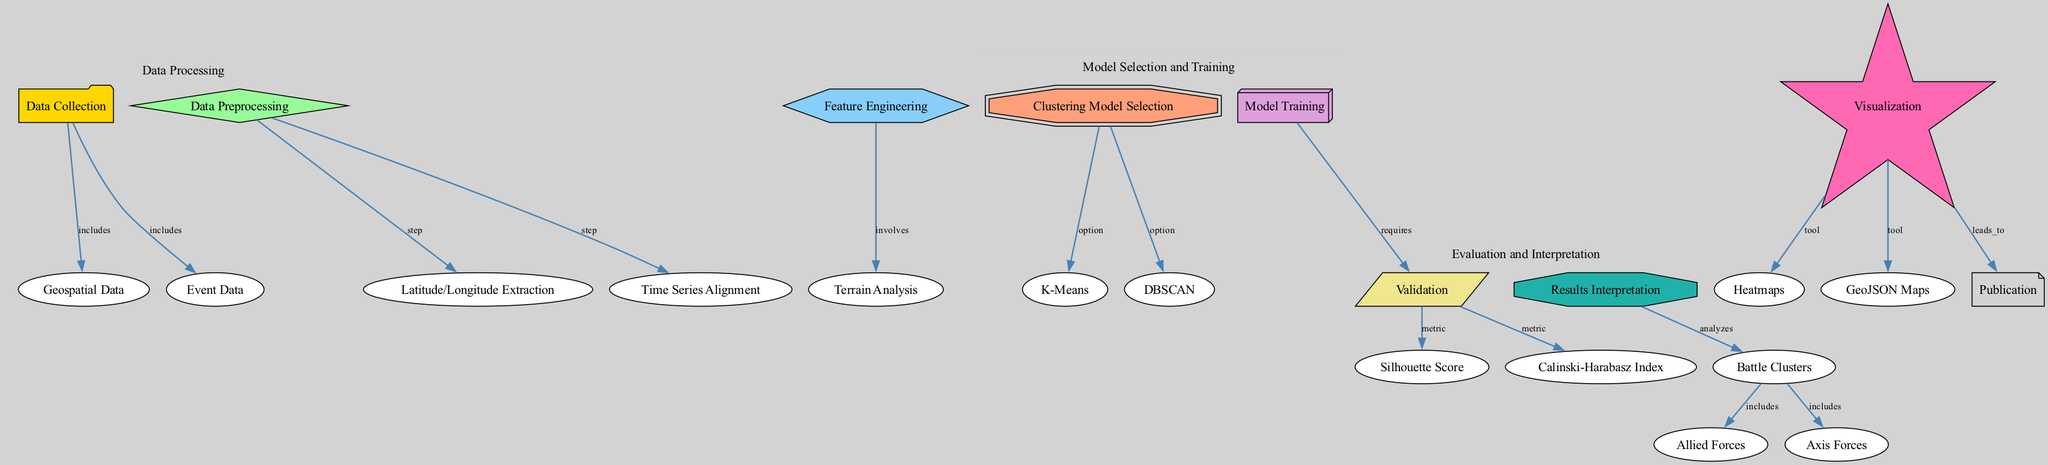What is the first step in the process? The diagram shows that "Data Collection" is the initial step, as it is the first node connected to others.
Answer: Data Collection How many clustering options are presented? By examining the "Clustering Model Selection" node, we see it connects to both "K-Means" and "DBSCAN," indicating there are two options.
Answer: 2 What does the "Validation" node measure? The "Validation" node has edges leading to "Silhouette Score" and "Calinski-Harabasz Index," revealing that it measures both metrics.
Answer: Silhouette Score and Calinski-Harabasz Index Which two clusters are included in the "Battle Clusters"? The "Battle Clusters" node connects to "Allied Forces" and "Axis Forces," indicating that both are part of the clusters analyzed.
Answer: Allied Forces and Axis Forces What is a tool used for visualization in this diagram? The "Visualization" node includes edges to both "Heatmaps" and "GeoJSON Maps," indicating you can use these tools for visualization.
Answer: Heatmaps and GeoJSON Maps What process follows the "Model Training" step? The arrow from "Model Training" points to "Validation," indicating that validation is the next step after training the model.
Answer: Validation Which step involves extracting geographic coordinates? The node "Latitude/Longitude Extraction" under the "Data Preprocessing" indicates this specific step involves extracting geographic coordinates.
Answer: Latitude/Longitude Extraction What analysis does "Results Interpretation" provide? The "Results Interpretation" node analyzes "Battle Clusters," showing that this step focuses on understanding the clusters of events.
Answer: Battle Clusters 